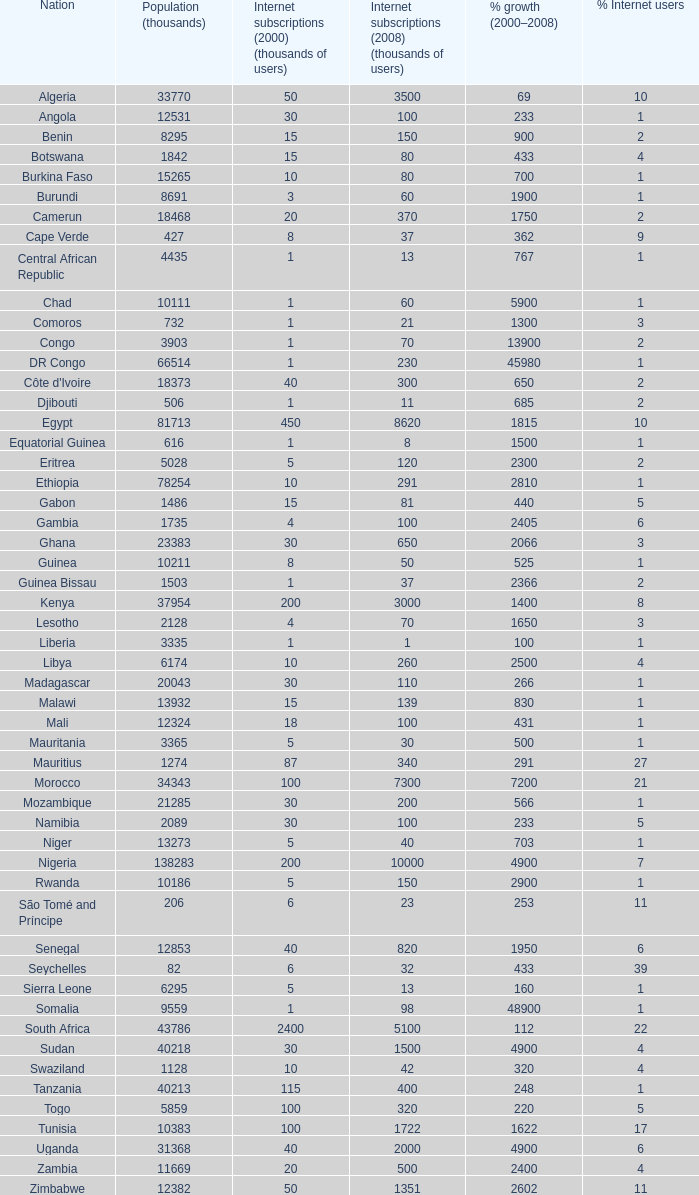What is the peak percentage growth between 2000-2008 in burundi? 1900.0. 